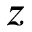Convert formula to latex. <formula><loc_0><loc_0><loc_500><loc_500>z</formula> 